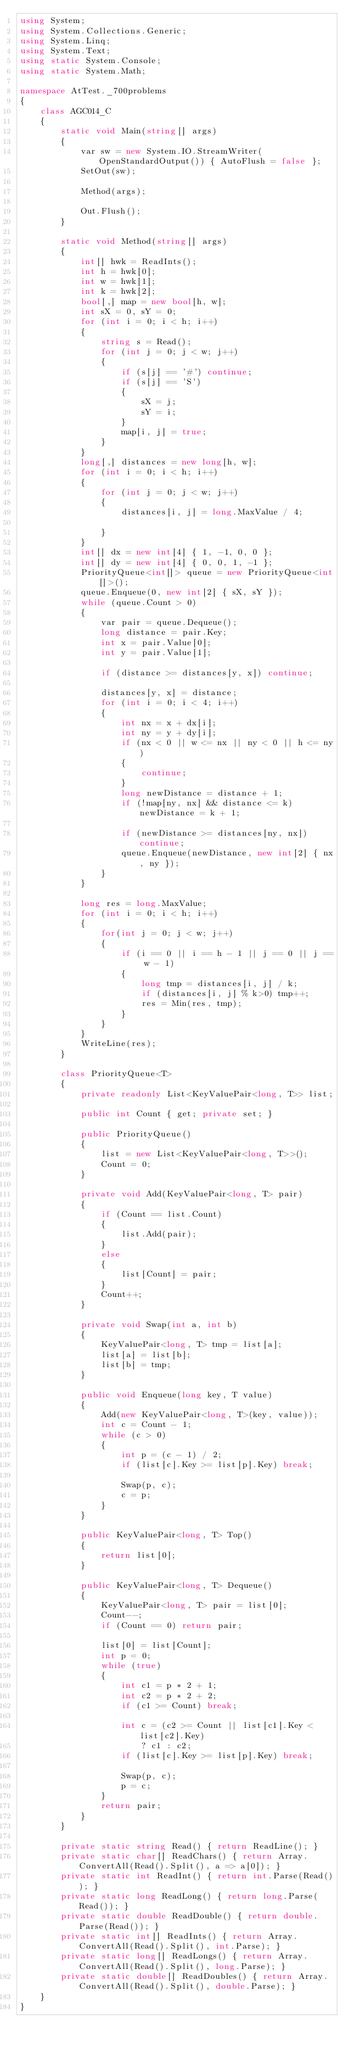Convert code to text. <code><loc_0><loc_0><loc_500><loc_500><_C#_>using System;
using System.Collections.Generic;
using System.Linq;
using System.Text;
using static System.Console;
using static System.Math;

namespace AtTest._700problems
{
    class AGC014_C
    {
        static void Main(string[] args)
        {
            var sw = new System.IO.StreamWriter(OpenStandardOutput()) { AutoFlush = false };
            SetOut(sw);

            Method(args);

            Out.Flush();
        }

        static void Method(string[] args)
        {
            int[] hwk = ReadInts();
            int h = hwk[0];
            int w = hwk[1];
            int k = hwk[2];
            bool[,] map = new bool[h, w];
            int sX = 0, sY = 0;
            for (int i = 0; i < h; i++)
            {
                string s = Read();
                for (int j = 0; j < w; j++)
                {
                    if (s[j] == '#') continue;
                    if (s[j] == 'S')
                    {
                        sX = j;
                        sY = i;
                    }
                    map[i, j] = true;
                }
            }
            long[,] distances = new long[h, w];
            for (int i = 0; i < h; i++)
            {
                for (int j = 0; j < w; j++)
                {
                    distances[i, j] = long.MaxValue / 4;

                }
            }
            int[] dx = new int[4] { 1, -1, 0, 0 };
            int[] dy = new int[4] { 0, 0, 1, -1 };
            PriorityQueue<int[]> queue = new PriorityQueue<int[]>();
            queue.Enqueue(0, new int[2] { sX, sY });
            while (queue.Count > 0)
            {
                var pair = queue.Dequeue();
                long distance = pair.Key;
                int x = pair.Value[0];
                int y = pair.Value[1];

                if (distance >= distances[y, x]) continue;

                distances[y, x] = distance;
                for (int i = 0; i < 4; i++)
                {
                    int nx = x + dx[i];
                    int ny = y + dy[i];
                    if (nx < 0 || w <= nx || ny < 0 || h <= ny)
                    {
                        continue;
                    }
                    long newDistance = distance + 1;
                    if (!map[ny, nx] && distance <= k) newDistance = k + 1;

                    if (newDistance >= distances[ny, nx]) continue;
                    queue.Enqueue(newDistance, new int[2] { nx, ny });
                }
            }

            long res = long.MaxValue;
            for (int i = 0; i < h; i++)
            {
                for(int j = 0; j < w; j++)
                {
                    if (i == 0 || i == h - 1 || j == 0 || j == w - 1)
                    {
                        long tmp = distances[i, j] / k;
                        if (distances[i, j] % k>0) tmp++;
                        res = Min(res, tmp);
                    }
                }
            }
            WriteLine(res);
        }

        class PriorityQueue<T>
        {
            private readonly List<KeyValuePair<long, T>> list;

            public int Count { get; private set; }

            public PriorityQueue()
            {
                list = new List<KeyValuePair<long, T>>();
                Count = 0;
            }

            private void Add(KeyValuePair<long, T> pair)
            {
                if (Count == list.Count)
                {
                    list.Add(pair);
                }
                else
                {
                    list[Count] = pair;
                }
                Count++;
            }

            private void Swap(int a, int b)
            {
                KeyValuePair<long, T> tmp = list[a];
                list[a] = list[b];
                list[b] = tmp;
            }

            public void Enqueue(long key, T value)
            {
                Add(new KeyValuePair<long, T>(key, value));
                int c = Count - 1;
                while (c > 0)
                {
                    int p = (c - 1) / 2;
                    if (list[c].Key >= list[p].Key) break;

                    Swap(p, c);
                    c = p;
                }
            }

            public KeyValuePair<long, T> Top()
            {
                return list[0];
            }

            public KeyValuePair<long, T> Dequeue()
            {
                KeyValuePair<long, T> pair = list[0];
                Count--;
                if (Count == 0) return pair;

                list[0] = list[Count];
                int p = 0;
                while (true)
                {
                    int c1 = p * 2 + 1;
                    int c2 = p * 2 + 2;
                    if (c1 >= Count) break;

                    int c = (c2 >= Count || list[c1].Key < list[c2].Key)
                        ? c1 : c2;
                    if (list[c].Key >= list[p].Key) break;

                    Swap(p, c);
                    p = c;
                }
                return pair;
            }
        }

        private static string Read() { return ReadLine(); }
        private static char[] ReadChars() { return Array.ConvertAll(Read().Split(), a => a[0]); }
        private static int ReadInt() { return int.Parse(Read()); }
        private static long ReadLong() { return long.Parse(Read()); }
        private static double ReadDouble() { return double.Parse(Read()); }
        private static int[] ReadInts() { return Array.ConvertAll(Read().Split(), int.Parse); }
        private static long[] ReadLongs() { return Array.ConvertAll(Read().Split(), long.Parse); }
        private static double[] ReadDoubles() { return Array.ConvertAll(Read().Split(), double.Parse); }
    }
}
</code> 